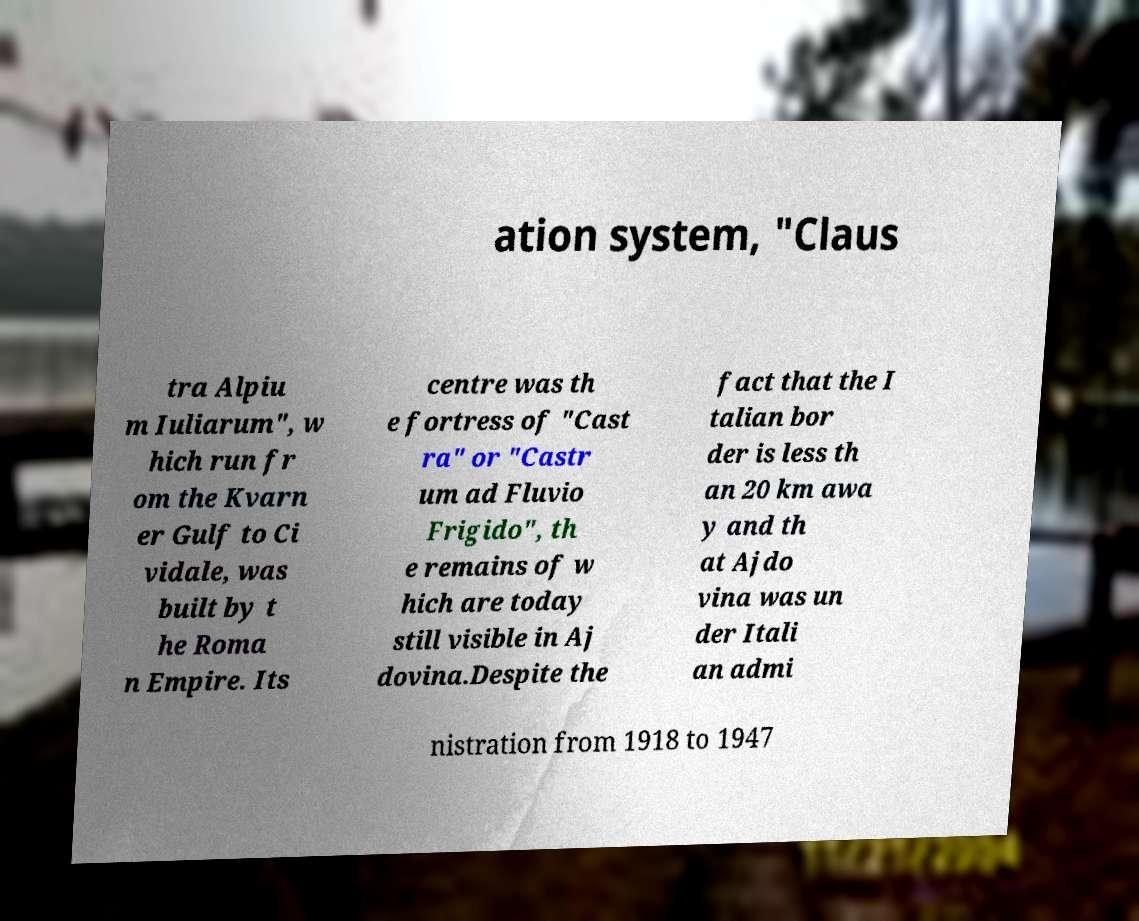For documentation purposes, I need the text within this image transcribed. Could you provide that? ation system, "Claus tra Alpiu m Iuliarum", w hich run fr om the Kvarn er Gulf to Ci vidale, was built by t he Roma n Empire. Its centre was th e fortress of "Cast ra" or "Castr um ad Fluvio Frigido", th e remains of w hich are today still visible in Aj dovina.Despite the fact that the I talian bor der is less th an 20 km awa y and th at Ajdo vina was un der Itali an admi nistration from 1918 to 1947 